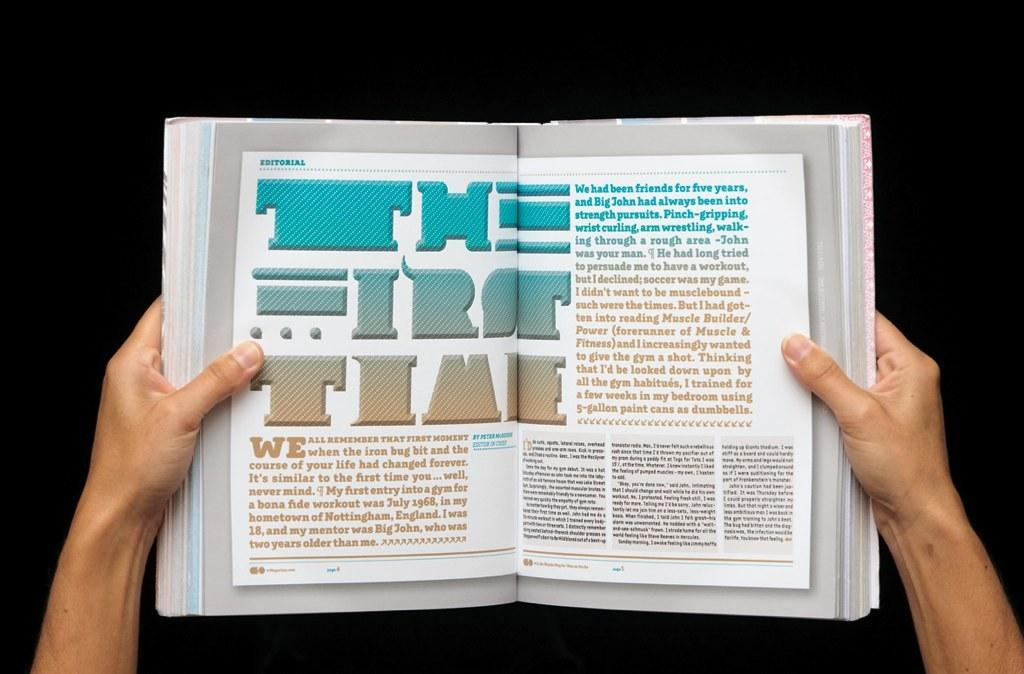<image>
Share a concise interpretation of the image provided. A man holds open a book with the writing THE FIRST TIME written on the pages. 